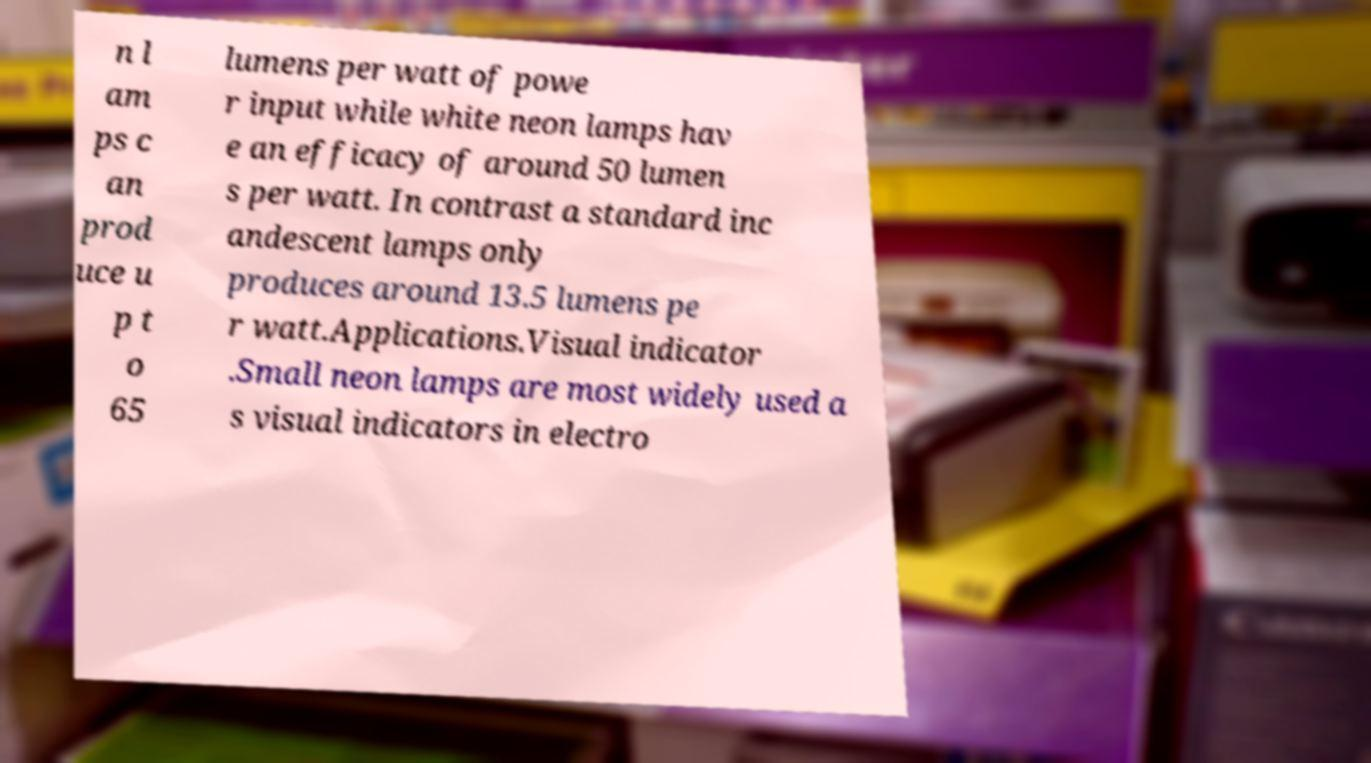Can you read and provide the text displayed in the image?This photo seems to have some interesting text. Can you extract and type it out for me? n l am ps c an prod uce u p t o 65 lumens per watt of powe r input while white neon lamps hav e an efficacy of around 50 lumen s per watt. In contrast a standard inc andescent lamps only produces around 13.5 lumens pe r watt.Applications.Visual indicator .Small neon lamps are most widely used a s visual indicators in electro 